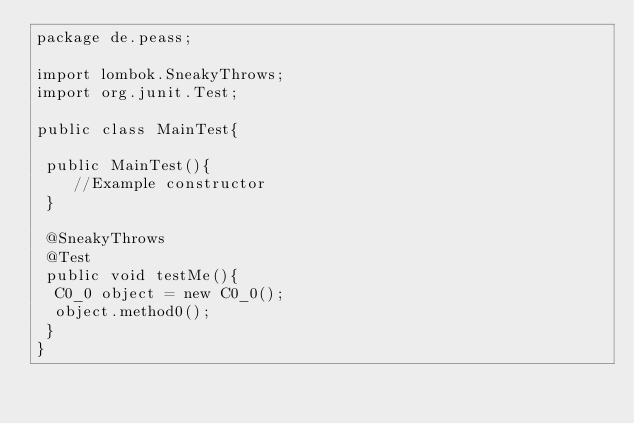<code> <loc_0><loc_0><loc_500><loc_500><_Java_>package de.peass;

import lombok.SneakyThrows;
import org.junit.Test;

public class MainTest{ 
 
 public MainTest(){
    //Example constructor
 }
	
 @SneakyThrows
 @Test 
 public void testMe(){
  C0_0 object = new C0_0();
  object.method0();
 }
}
</code> 